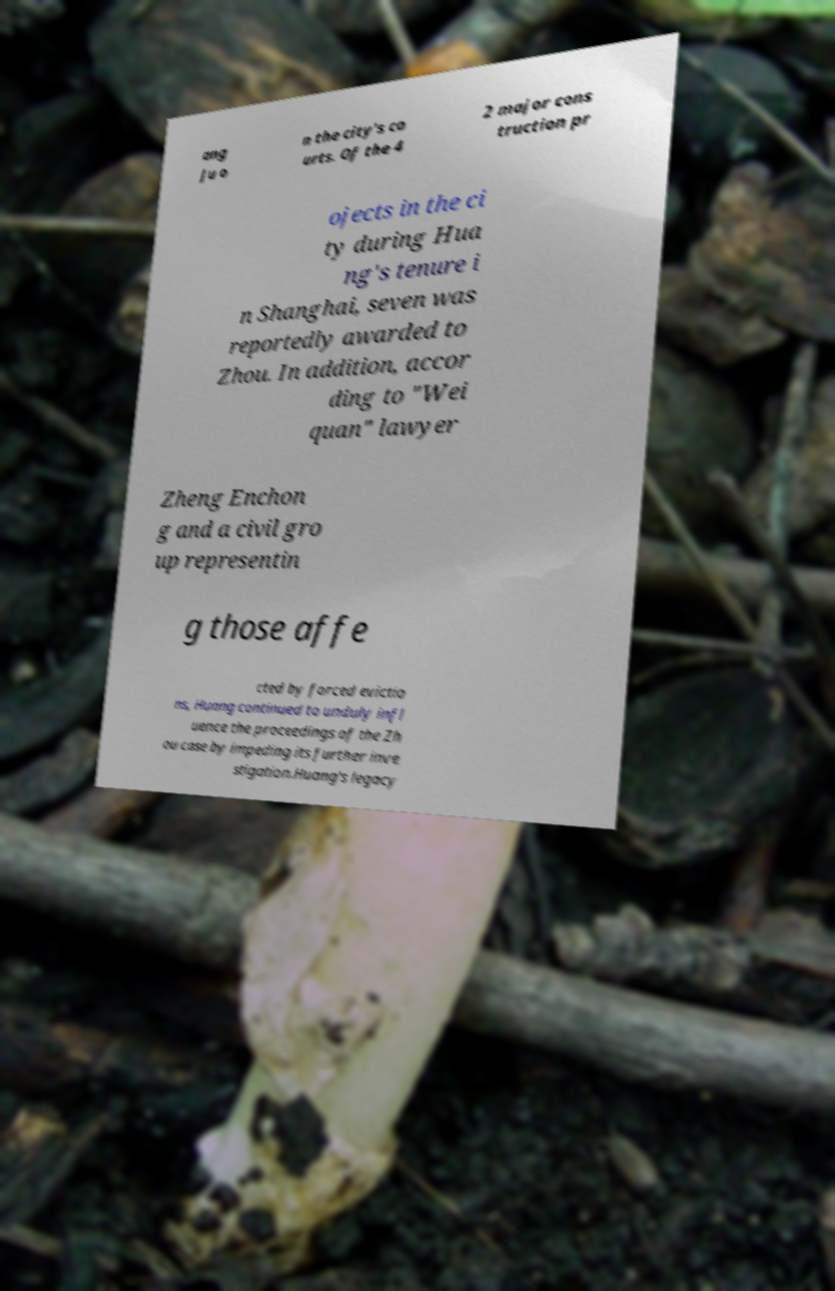Can you read and provide the text displayed in the image?This photo seems to have some interesting text. Can you extract and type it out for me? ang Ju o n the city's co urts. Of the 4 2 major cons truction pr ojects in the ci ty during Hua ng's tenure i n Shanghai, seven was reportedly awarded to Zhou. In addition, accor ding to "Wei quan" lawyer Zheng Enchon g and a civil gro up representin g those affe cted by forced evictio ns, Huang continued to unduly infl uence the proceedings of the Zh ou case by impeding its further inve stigation.Huang's legacy 